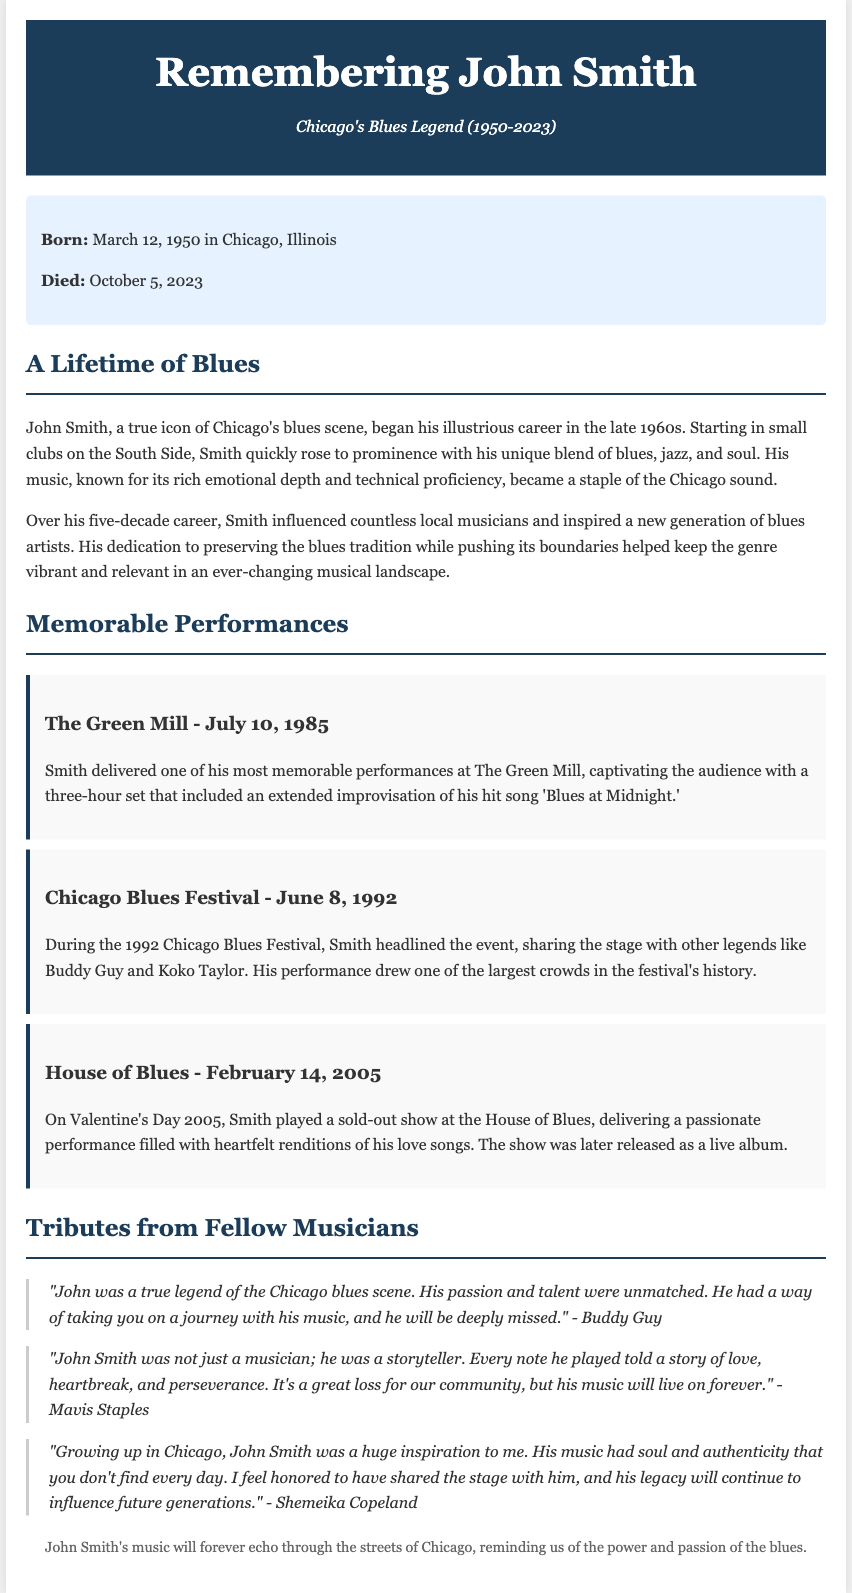what was John Smith's birth date? The document states that John Smith was born on March 12, 1950.
Answer: March 12, 1950 what year did John Smith die? The obituary mentions that John Smith died on October 5, 2023.
Answer: October 5, 2023 which venue hosted a memorable performance by John Smith on July 10, 1985? The document specifies that John Smith delivered a memorable performance at The Green Mill on July 10, 1985.
Answer: The Green Mill who headlined the Chicago Blues Festival in 1992? The document indicates that John Smith headlined the Chicago Blues Festival in 1992.
Answer: John Smith how did John Smith influence local musicians? The obituary explains that Smith influenced countless local musicians and inspired a new generation of blues artists.
Answer: Inspired a new generation of blues artists what genre did John Smith blend in his music? The document notes that John Smith blended blues, jazz, and soul in his music.
Answer: Blues, jazz, and soul which musician said "His passion and talent were unmatched"? According to the document, Buddy Guy made the statement about John Smith's talent and passion.
Answer: Buddy Guy what was released from John Smith's Valentine's Day performance in 2005? The document mentions that the performance at the House of Blues was later released as a live album.
Answer: A live album what impact did John Smith have on the blues genre? The obituary states that his dedication helped keep the blues genre vibrant and relevant.
Answer: Kept the blues genre vibrant and relevant 